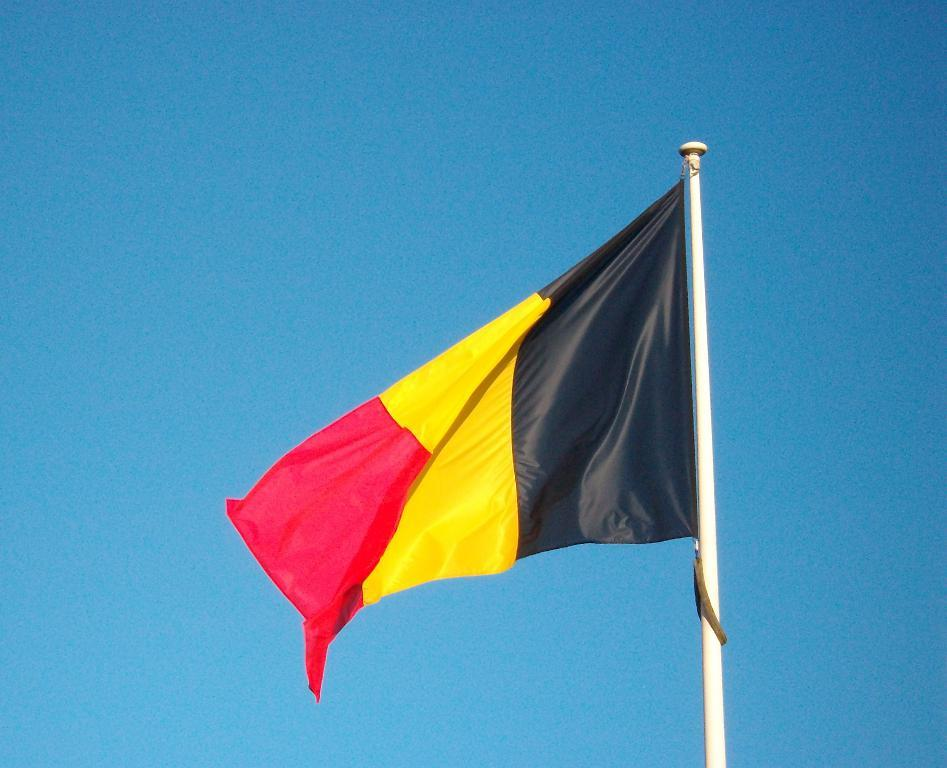What is the main object in the image? There is a flag in the image. How is the flag displayed? The flag is on a pole. What color is the background of the image? The background of the image is blue. What is the price of the cent in the image? There is no cent present in the image, so it is not possible to determine its price. 